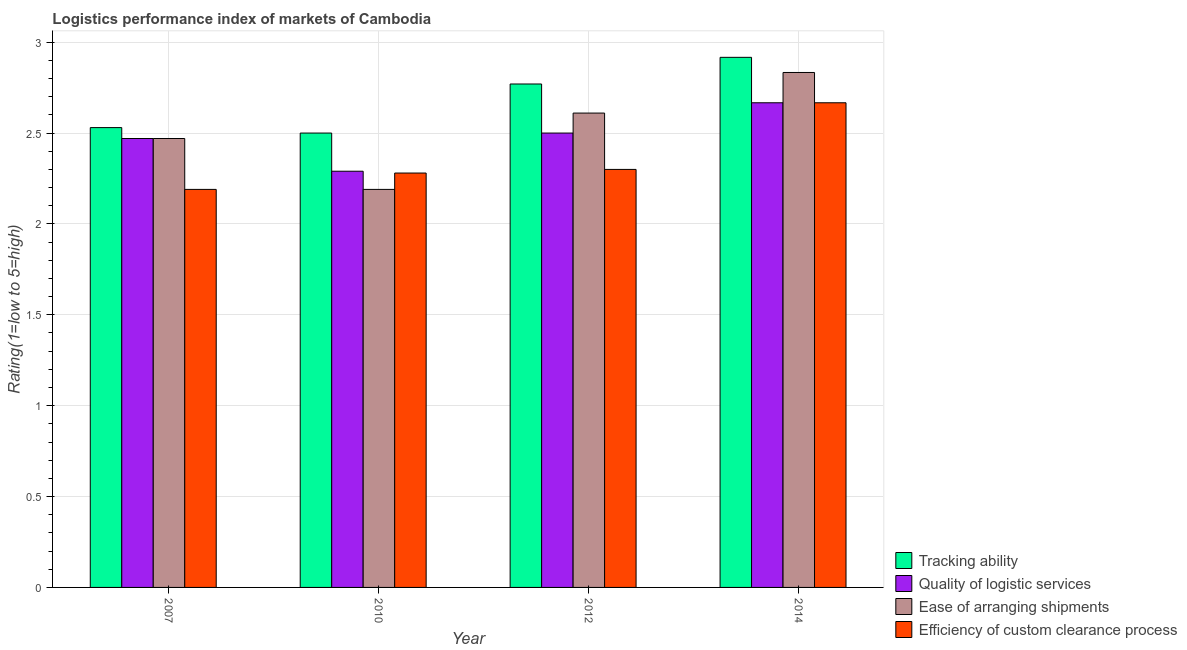How many groups of bars are there?
Offer a terse response. 4. How many bars are there on the 4th tick from the right?
Ensure brevity in your answer.  4. In how many cases, is the number of bars for a given year not equal to the number of legend labels?
Make the answer very short. 0. What is the lpi rating of efficiency of custom clearance process in 2007?
Offer a terse response. 2.19. Across all years, what is the maximum lpi rating of efficiency of custom clearance process?
Your answer should be compact. 2.67. Across all years, what is the minimum lpi rating of tracking ability?
Ensure brevity in your answer.  2.5. In which year was the lpi rating of ease of arranging shipments maximum?
Your answer should be very brief. 2014. What is the total lpi rating of tracking ability in the graph?
Your response must be concise. 10.72. What is the difference between the lpi rating of tracking ability in 2012 and that in 2014?
Offer a very short reply. -0.15. What is the difference between the lpi rating of quality of logistic services in 2014 and the lpi rating of efficiency of custom clearance process in 2012?
Make the answer very short. 0.17. What is the average lpi rating of efficiency of custom clearance process per year?
Offer a very short reply. 2.36. In the year 2014, what is the difference between the lpi rating of quality of logistic services and lpi rating of tracking ability?
Keep it short and to the point. 0. In how many years, is the lpi rating of ease of arranging shipments greater than 1?
Provide a short and direct response. 4. What is the ratio of the lpi rating of tracking ability in 2012 to that in 2014?
Your answer should be compact. 0.95. Is the difference between the lpi rating of tracking ability in 2010 and 2014 greater than the difference between the lpi rating of quality of logistic services in 2010 and 2014?
Your response must be concise. No. What is the difference between the highest and the second highest lpi rating of tracking ability?
Make the answer very short. 0.15. What is the difference between the highest and the lowest lpi rating of quality of logistic services?
Make the answer very short. 0.38. In how many years, is the lpi rating of tracking ability greater than the average lpi rating of tracking ability taken over all years?
Your response must be concise. 2. Is the sum of the lpi rating of ease of arranging shipments in 2010 and 2012 greater than the maximum lpi rating of quality of logistic services across all years?
Ensure brevity in your answer.  Yes. What does the 1st bar from the left in 2007 represents?
Provide a short and direct response. Tracking ability. What does the 2nd bar from the right in 2012 represents?
Ensure brevity in your answer.  Ease of arranging shipments. Is it the case that in every year, the sum of the lpi rating of tracking ability and lpi rating of quality of logistic services is greater than the lpi rating of ease of arranging shipments?
Make the answer very short. Yes. Are all the bars in the graph horizontal?
Offer a very short reply. No. How many years are there in the graph?
Give a very brief answer. 4. What is the difference between two consecutive major ticks on the Y-axis?
Your answer should be very brief. 0.5. Are the values on the major ticks of Y-axis written in scientific E-notation?
Offer a terse response. No. Where does the legend appear in the graph?
Your response must be concise. Bottom right. How many legend labels are there?
Give a very brief answer. 4. How are the legend labels stacked?
Provide a short and direct response. Vertical. What is the title of the graph?
Your answer should be very brief. Logistics performance index of markets of Cambodia. Does "UNAIDS" appear as one of the legend labels in the graph?
Ensure brevity in your answer.  No. What is the label or title of the X-axis?
Ensure brevity in your answer.  Year. What is the label or title of the Y-axis?
Your answer should be compact. Rating(1=low to 5=high). What is the Rating(1=low to 5=high) of Tracking ability in 2007?
Ensure brevity in your answer.  2.53. What is the Rating(1=low to 5=high) of Quality of logistic services in 2007?
Offer a very short reply. 2.47. What is the Rating(1=low to 5=high) of Ease of arranging shipments in 2007?
Keep it short and to the point. 2.47. What is the Rating(1=low to 5=high) of Efficiency of custom clearance process in 2007?
Your answer should be very brief. 2.19. What is the Rating(1=low to 5=high) in Tracking ability in 2010?
Offer a terse response. 2.5. What is the Rating(1=low to 5=high) of Quality of logistic services in 2010?
Your answer should be very brief. 2.29. What is the Rating(1=low to 5=high) of Ease of arranging shipments in 2010?
Offer a terse response. 2.19. What is the Rating(1=low to 5=high) of Efficiency of custom clearance process in 2010?
Your answer should be very brief. 2.28. What is the Rating(1=low to 5=high) in Tracking ability in 2012?
Your answer should be compact. 2.77. What is the Rating(1=low to 5=high) in Quality of logistic services in 2012?
Make the answer very short. 2.5. What is the Rating(1=low to 5=high) of Ease of arranging shipments in 2012?
Provide a short and direct response. 2.61. What is the Rating(1=low to 5=high) of Efficiency of custom clearance process in 2012?
Your response must be concise. 2.3. What is the Rating(1=low to 5=high) of Tracking ability in 2014?
Offer a terse response. 2.92. What is the Rating(1=low to 5=high) in Quality of logistic services in 2014?
Offer a very short reply. 2.67. What is the Rating(1=low to 5=high) of Ease of arranging shipments in 2014?
Your response must be concise. 2.83. What is the Rating(1=low to 5=high) of Efficiency of custom clearance process in 2014?
Ensure brevity in your answer.  2.67. Across all years, what is the maximum Rating(1=low to 5=high) of Tracking ability?
Make the answer very short. 2.92. Across all years, what is the maximum Rating(1=low to 5=high) of Quality of logistic services?
Ensure brevity in your answer.  2.67. Across all years, what is the maximum Rating(1=low to 5=high) in Ease of arranging shipments?
Keep it short and to the point. 2.83. Across all years, what is the maximum Rating(1=low to 5=high) of Efficiency of custom clearance process?
Offer a terse response. 2.67. Across all years, what is the minimum Rating(1=low to 5=high) of Quality of logistic services?
Provide a succinct answer. 2.29. Across all years, what is the minimum Rating(1=low to 5=high) of Ease of arranging shipments?
Provide a succinct answer. 2.19. Across all years, what is the minimum Rating(1=low to 5=high) in Efficiency of custom clearance process?
Offer a very short reply. 2.19. What is the total Rating(1=low to 5=high) of Tracking ability in the graph?
Give a very brief answer. 10.72. What is the total Rating(1=low to 5=high) in Quality of logistic services in the graph?
Your answer should be very brief. 9.93. What is the total Rating(1=low to 5=high) in Ease of arranging shipments in the graph?
Keep it short and to the point. 10.1. What is the total Rating(1=low to 5=high) of Efficiency of custom clearance process in the graph?
Make the answer very short. 9.44. What is the difference between the Rating(1=low to 5=high) in Quality of logistic services in 2007 and that in 2010?
Offer a terse response. 0.18. What is the difference between the Rating(1=low to 5=high) of Ease of arranging shipments in 2007 and that in 2010?
Keep it short and to the point. 0.28. What is the difference between the Rating(1=low to 5=high) in Efficiency of custom clearance process in 2007 and that in 2010?
Your answer should be compact. -0.09. What is the difference between the Rating(1=low to 5=high) of Tracking ability in 2007 and that in 2012?
Give a very brief answer. -0.24. What is the difference between the Rating(1=low to 5=high) in Quality of logistic services in 2007 and that in 2012?
Offer a very short reply. -0.03. What is the difference between the Rating(1=low to 5=high) of Ease of arranging shipments in 2007 and that in 2012?
Your response must be concise. -0.14. What is the difference between the Rating(1=low to 5=high) in Efficiency of custom clearance process in 2007 and that in 2012?
Provide a short and direct response. -0.11. What is the difference between the Rating(1=low to 5=high) in Tracking ability in 2007 and that in 2014?
Give a very brief answer. -0.39. What is the difference between the Rating(1=low to 5=high) in Quality of logistic services in 2007 and that in 2014?
Give a very brief answer. -0.2. What is the difference between the Rating(1=low to 5=high) in Ease of arranging shipments in 2007 and that in 2014?
Provide a short and direct response. -0.36. What is the difference between the Rating(1=low to 5=high) of Efficiency of custom clearance process in 2007 and that in 2014?
Your response must be concise. -0.48. What is the difference between the Rating(1=low to 5=high) in Tracking ability in 2010 and that in 2012?
Offer a very short reply. -0.27. What is the difference between the Rating(1=low to 5=high) of Quality of logistic services in 2010 and that in 2012?
Provide a succinct answer. -0.21. What is the difference between the Rating(1=low to 5=high) in Ease of arranging shipments in 2010 and that in 2012?
Give a very brief answer. -0.42. What is the difference between the Rating(1=low to 5=high) in Efficiency of custom clearance process in 2010 and that in 2012?
Keep it short and to the point. -0.02. What is the difference between the Rating(1=low to 5=high) of Tracking ability in 2010 and that in 2014?
Your answer should be compact. -0.42. What is the difference between the Rating(1=low to 5=high) of Quality of logistic services in 2010 and that in 2014?
Your response must be concise. -0.38. What is the difference between the Rating(1=low to 5=high) in Ease of arranging shipments in 2010 and that in 2014?
Your answer should be compact. -0.64. What is the difference between the Rating(1=low to 5=high) of Efficiency of custom clearance process in 2010 and that in 2014?
Offer a terse response. -0.39. What is the difference between the Rating(1=low to 5=high) in Tracking ability in 2012 and that in 2014?
Make the answer very short. -0.15. What is the difference between the Rating(1=low to 5=high) of Ease of arranging shipments in 2012 and that in 2014?
Your answer should be very brief. -0.22. What is the difference between the Rating(1=low to 5=high) of Efficiency of custom clearance process in 2012 and that in 2014?
Provide a succinct answer. -0.37. What is the difference between the Rating(1=low to 5=high) of Tracking ability in 2007 and the Rating(1=low to 5=high) of Quality of logistic services in 2010?
Offer a very short reply. 0.24. What is the difference between the Rating(1=low to 5=high) of Tracking ability in 2007 and the Rating(1=low to 5=high) of Ease of arranging shipments in 2010?
Your answer should be compact. 0.34. What is the difference between the Rating(1=low to 5=high) in Tracking ability in 2007 and the Rating(1=low to 5=high) in Efficiency of custom clearance process in 2010?
Provide a short and direct response. 0.25. What is the difference between the Rating(1=low to 5=high) of Quality of logistic services in 2007 and the Rating(1=low to 5=high) of Ease of arranging shipments in 2010?
Your response must be concise. 0.28. What is the difference between the Rating(1=low to 5=high) in Quality of logistic services in 2007 and the Rating(1=low to 5=high) in Efficiency of custom clearance process in 2010?
Keep it short and to the point. 0.19. What is the difference between the Rating(1=low to 5=high) of Ease of arranging shipments in 2007 and the Rating(1=low to 5=high) of Efficiency of custom clearance process in 2010?
Your answer should be very brief. 0.19. What is the difference between the Rating(1=low to 5=high) of Tracking ability in 2007 and the Rating(1=low to 5=high) of Ease of arranging shipments in 2012?
Ensure brevity in your answer.  -0.08. What is the difference between the Rating(1=low to 5=high) in Tracking ability in 2007 and the Rating(1=low to 5=high) in Efficiency of custom clearance process in 2012?
Your answer should be compact. 0.23. What is the difference between the Rating(1=low to 5=high) of Quality of logistic services in 2007 and the Rating(1=low to 5=high) of Ease of arranging shipments in 2012?
Offer a terse response. -0.14. What is the difference between the Rating(1=low to 5=high) in Quality of logistic services in 2007 and the Rating(1=low to 5=high) in Efficiency of custom clearance process in 2012?
Offer a very short reply. 0.17. What is the difference between the Rating(1=low to 5=high) of Ease of arranging shipments in 2007 and the Rating(1=low to 5=high) of Efficiency of custom clearance process in 2012?
Provide a succinct answer. 0.17. What is the difference between the Rating(1=low to 5=high) in Tracking ability in 2007 and the Rating(1=low to 5=high) in Quality of logistic services in 2014?
Offer a terse response. -0.14. What is the difference between the Rating(1=low to 5=high) in Tracking ability in 2007 and the Rating(1=low to 5=high) in Ease of arranging shipments in 2014?
Your answer should be very brief. -0.3. What is the difference between the Rating(1=low to 5=high) in Tracking ability in 2007 and the Rating(1=low to 5=high) in Efficiency of custom clearance process in 2014?
Keep it short and to the point. -0.14. What is the difference between the Rating(1=low to 5=high) in Quality of logistic services in 2007 and the Rating(1=low to 5=high) in Ease of arranging shipments in 2014?
Provide a succinct answer. -0.36. What is the difference between the Rating(1=low to 5=high) of Quality of logistic services in 2007 and the Rating(1=low to 5=high) of Efficiency of custom clearance process in 2014?
Your answer should be very brief. -0.2. What is the difference between the Rating(1=low to 5=high) in Ease of arranging shipments in 2007 and the Rating(1=low to 5=high) in Efficiency of custom clearance process in 2014?
Provide a succinct answer. -0.2. What is the difference between the Rating(1=low to 5=high) in Tracking ability in 2010 and the Rating(1=low to 5=high) in Quality of logistic services in 2012?
Your answer should be compact. 0. What is the difference between the Rating(1=low to 5=high) in Tracking ability in 2010 and the Rating(1=low to 5=high) in Ease of arranging shipments in 2012?
Give a very brief answer. -0.11. What is the difference between the Rating(1=low to 5=high) of Quality of logistic services in 2010 and the Rating(1=low to 5=high) of Ease of arranging shipments in 2012?
Give a very brief answer. -0.32. What is the difference between the Rating(1=low to 5=high) in Quality of logistic services in 2010 and the Rating(1=low to 5=high) in Efficiency of custom clearance process in 2012?
Make the answer very short. -0.01. What is the difference between the Rating(1=low to 5=high) in Ease of arranging shipments in 2010 and the Rating(1=low to 5=high) in Efficiency of custom clearance process in 2012?
Provide a succinct answer. -0.11. What is the difference between the Rating(1=low to 5=high) of Tracking ability in 2010 and the Rating(1=low to 5=high) of Quality of logistic services in 2014?
Your answer should be compact. -0.17. What is the difference between the Rating(1=low to 5=high) in Tracking ability in 2010 and the Rating(1=low to 5=high) in Ease of arranging shipments in 2014?
Your answer should be very brief. -0.33. What is the difference between the Rating(1=low to 5=high) of Tracking ability in 2010 and the Rating(1=low to 5=high) of Efficiency of custom clearance process in 2014?
Your answer should be very brief. -0.17. What is the difference between the Rating(1=low to 5=high) in Quality of logistic services in 2010 and the Rating(1=low to 5=high) in Ease of arranging shipments in 2014?
Your answer should be very brief. -0.54. What is the difference between the Rating(1=low to 5=high) in Quality of logistic services in 2010 and the Rating(1=low to 5=high) in Efficiency of custom clearance process in 2014?
Offer a terse response. -0.38. What is the difference between the Rating(1=low to 5=high) in Ease of arranging shipments in 2010 and the Rating(1=low to 5=high) in Efficiency of custom clearance process in 2014?
Your answer should be very brief. -0.48. What is the difference between the Rating(1=low to 5=high) in Tracking ability in 2012 and the Rating(1=low to 5=high) in Quality of logistic services in 2014?
Offer a terse response. 0.1. What is the difference between the Rating(1=low to 5=high) in Tracking ability in 2012 and the Rating(1=low to 5=high) in Ease of arranging shipments in 2014?
Your answer should be compact. -0.06. What is the difference between the Rating(1=low to 5=high) in Tracking ability in 2012 and the Rating(1=low to 5=high) in Efficiency of custom clearance process in 2014?
Provide a succinct answer. 0.1. What is the difference between the Rating(1=low to 5=high) in Quality of logistic services in 2012 and the Rating(1=low to 5=high) in Ease of arranging shipments in 2014?
Provide a short and direct response. -0.33. What is the difference between the Rating(1=low to 5=high) of Ease of arranging shipments in 2012 and the Rating(1=low to 5=high) of Efficiency of custom clearance process in 2014?
Offer a terse response. -0.06. What is the average Rating(1=low to 5=high) of Tracking ability per year?
Keep it short and to the point. 2.68. What is the average Rating(1=low to 5=high) in Quality of logistic services per year?
Provide a succinct answer. 2.48. What is the average Rating(1=low to 5=high) of Ease of arranging shipments per year?
Ensure brevity in your answer.  2.53. What is the average Rating(1=low to 5=high) of Efficiency of custom clearance process per year?
Provide a succinct answer. 2.36. In the year 2007, what is the difference between the Rating(1=low to 5=high) of Tracking ability and Rating(1=low to 5=high) of Quality of logistic services?
Your answer should be compact. 0.06. In the year 2007, what is the difference between the Rating(1=low to 5=high) of Tracking ability and Rating(1=low to 5=high) of Ease of arranging shipments?
Provide a short and direct response. 0.06. In the year 2007, what is the difference between the Rating(1=low to 5=high) of Tracking ability and Rating(1=low to 5=high) of Efficiency of custom clearance process?
Provide a short and direct response. 0.34. In the year 2007, what is the difference between the Rating(1=low to 5=high) of Quality of logistic services and Rating(1=low to 5=high) of Efficiency of custom clearance process?
Offer a very short reply. 0.28. In the year 2007, what is the difference between the Rating(1=low to 5=high) of Ease of arranging shipments and Rating(1=low to 5=high) of Efficiency of custom clearance process?
Provide a succinct answer. 0.28. In the year 2010, what is the difference between the Rating(1=low to 5=high) of Tracking ability and Rating(1=low to 5=high) of Quality of logistic services?
Offer a very short reply. 0.21. In the year 2010, what is the difference between the Rating(1=low to 5=high) of Tracking ability and Rating(1=low to 5=high) of Ease of arranging shipments?
Provide a short and direct response. 0.31. In the year 2010, what is the difference between the Rating(1=low to 5=high) in Tracking ability and Rating(1=low to 5=high) in Efficiency of custom clearance process?
Ensure brevity in your answer.  0.22. In the year 2010, what is the difference between the Rating(1=low to 5=high) of Quality of logistic services and Rating(1=low to 5=high) of Ease of arranging shipments?
Provide a succinct answer. 0.1. In the year 2010, what is the difference between the Rating(1=low to 5=high) of Quality of logistic services and Rating(1=low to 5=high) of Efficiency of custom clearance process?
Your response must be concise. 0.01. In the year 2010, what is the difference between the Rating(1=low to 5=high) in Ease of arranging shipments and Rating(1=low to 5=high) in Efficiency of custom clearance process?
Give a very brief answer. -0.09. In the year 2012, what is the difference between the Rating(1=low to 5=high) in Tracking ability and Rating(1=low to 5=high) in Quality of logistic services?
Give a very brief answer. 0.27. In the year 2012, what is the difference between the Rating(1=low to 5=high) of Tracking ability and Rating(1=low to 5=high) of Ease of arranging shipments?
Provide a short and direct response. 0.16. In the year 2012, what is the difference between the Rating(1=low to 5=high) of Tracking ability and Rating(1=low to 5=high) of Efficiency of custom clearance process?
Keep it short and to the point. 0.47. In the year 2012, what is the difference between the Rating(1=low to 5=high) in Quality of logistic services and Rating(1=low to 5=high) in Ease of arranging shipments?
Offer a terse response. -0.11. In the year 2012, what is the difference between the Rating(1=low to 5=high) in Quality of logistic services and Rating(1=low to 5=high) in Efficiency of custom clearance process?
Your response must be concise. 0.2. In the year 2012, what is the difference between the Rating(1=low to 5=high) of Ease of arranging shipments and Rating(1=low to 5=high) of Efficiency of custom clearance process?
Provide a succinct answer. 0.31. In the year 2014, what is the difference between the Rating(1=low to 5=high) of Tracking ability and Rating(1=low to 5=high) of Ease of arranging shipments?
Your answer should be compact. 0.08. In the year 2014, what is the difference between the Rating(1=low to 5=high) in Quality of logistic services and Rating(1=low to 5=high) in Efficiency of custom clearance process?
Offer a very short reply. 0. What is the ratio of the Rating(1=low to 5=high) of Quality of logistic services in 2007 to that in 2010?
Give a very brief answer. 1.08. What is the ratio of the Rating(1=low to 5=high) in Ease of arranging shipments in 2007 to that in 2010?
Provide a short and direct response. 1.13. What is the ratio of the Rating(1=low to 5=high) in Efficiency of custom clearance process in 2007 to that in 2010?
Your answer should be compact. 0.96. What is the ratio of the Rating(1=low to 5=high) of Tracking ability in 2007 to that in 2012?
Give a very brief answer. 0.91. What is the ratio of the Rating(1=low to 5=high) in Ease of arranging shipments in 2007 to that in 2012?
Your answer should be very brief. 0.95. What is the ratio of the Rating(1=low to 5=high) in Efficiency of custom clearance process in 2007 to that in 2012?
Provide a short and direct response. 0.95. What is the ratio of the Rating(1=low to 5=high) in Tracking ability in 2007 to that in 2014?
Offer a terse response. 0.87. What is the ratio of the Rating(1=low to 5=high) of Quality of logistic services in 2007 to that in 2014?
Provide a short and direct response. 0.93. What is the ratio of the Rating(1=low to 5=high) in Ease of arranging shipments in 2007 to that in 2014?
Offer a very short reply. 0.87. What is the ratio of the Rating(1=low to 5=high) in Efficiency of custom clearance process in 2007 to that in 2014?
Your answer should be compact. 0.82. What is the ratio of the Rating(1=low to 5=high) in Tracking ability in 2010 to that in 2012?
Keep it short and to the point. 0.9. What is the ratio of the Rating(1=low to 5=high) in Quality of logistic services in 2010 to that in 2012?
Give a very brief answer. 0.92. What is the ratio of the Rating(1=low to 5=high) of Ease of arranging shipments in 2010 to that in 2012?
Keep it short and to the point. 0.84. What is the ratio of the Rating(1=low to 5=high) in Tracking ability in 2010 to that in 2014?
Give a very brief answer. 0.86. What is the ratio of the Rating(1=low to 5=high) in Quality of logistic services in 2010 to that in 2014?
Provide a succinct answer. 0.86. What is the ratio of the Rating(1=low to 5=high) of Ease of arranging shipments in 2010 to that in 2014?
Give a very brief answer. 0.77. What is the ratio of the Rating(1=low to 5=high) in Efficiency of custom clearance process in 2010 to that in 2014?
Make the answer very short. 0.85. What is the ratio of the Rating(1=low to 5=high) in Tracking ability in 2012 to that in 2014?
Make the answer very short. 0.95. What is the ratio of the Rating(1=low to 5=high) of Quality of logistic services in 2012 to that in 2014?
Your answer should be compact. 0.94. What is the ratio of the Rating(1=low to 5=high) of Ease of arranging shipments in 2012 to that in 2014?
Ensure brevity in your answer.  0.92. What is the ratio of the Rating(1=low to 5=high) of Efficiency of custom clearance process in 2012 to that in 2014?
Your answer should be compact. 0.86. What is the difference between the highest and the second highest Rating(1=low to 5=high) of Tracking ability?
Your response must be concise. 0.15. What is the difference between the highest and the second highest Rating(1=low to 5=high) in Ease of arranging shipments?
Provide a short and direct response. 0.22. What is the difference between the highest and the second highest Rating(1=low to 5=high) of Efficiency of custom clearance process?
Your answer should be very brief. 0.37. What is the difference between the highest and the lowest Rating(1=low to 5=high) in Tracking ability?
Provide a short and direct response. 0.42. What is the difference between the highest and the lowest Rating(1=low to 5=high) of Quality of logistic services?
Keep it short and to the point. 0.38. What is the difference between the highest and the lowest Rating(1=low to 5=high) of Ease of arranging shipments?
Your response must be concise. 0.64. What is the difference between the highest and the lowest Rating(1=low to 5=high) of Efficiency of custom clearance process?
Your answer should be very brief. 0.48. 